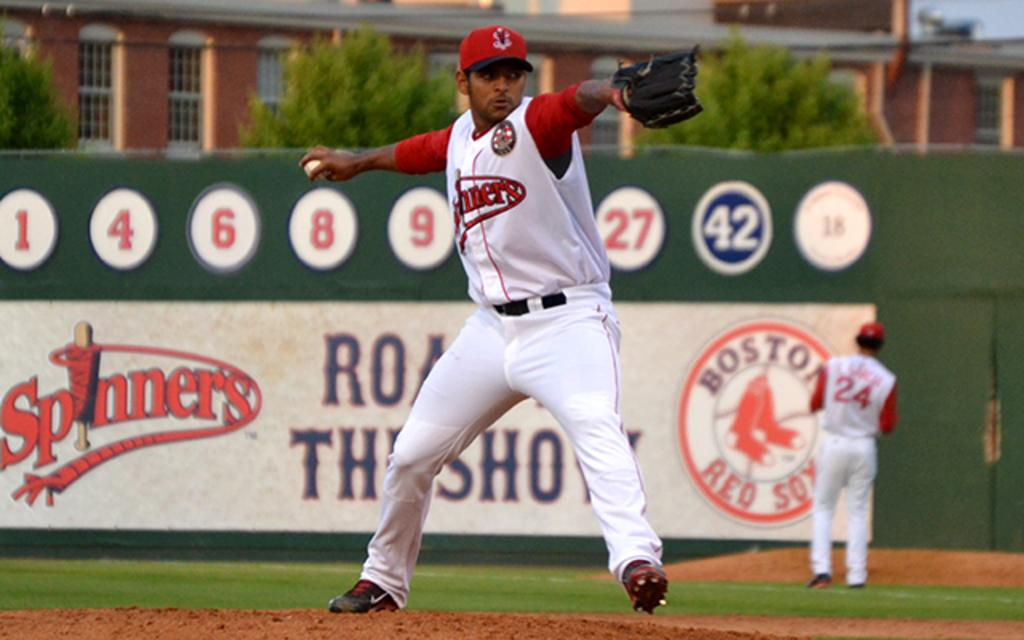<image>
Relay a brief, clear account of the picture shown. Boston spinners baseball team is out playing baseball 